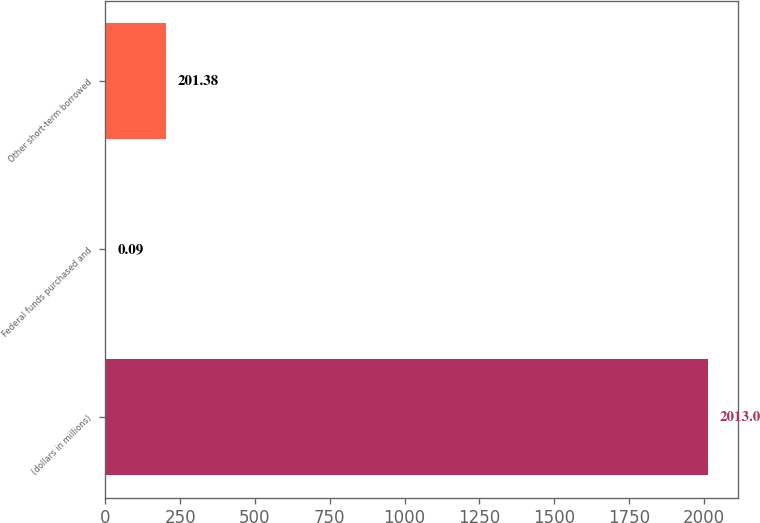Convert chart to OTSL. <chart><loc_0><loc_0><loc_500><loc_500><bar_chart><fcel>(dollars in millions)<fcel>Federal funds purchased and<fcel>Other short-term borrowed<nl><fcel>2013<fcel>0.09<fcel>201.38<nl></chart> 